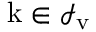Convert formula to latex. <formula><loc_0><loc_0><loc_500><loc_500>{ k } \in \mathcal { I } _ { v }</formula> 